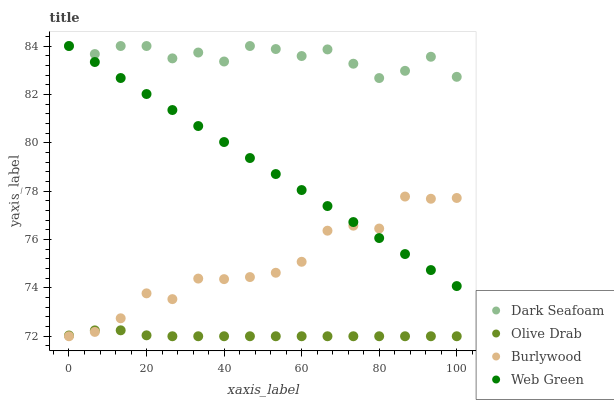Does Olive Drab have the minimum area under the curve?
Answer yes or no. Yes. Does Dark Seafoam have the maximum area under the curve?
Answer yes or no. Yes. Does Web Green have the minimum area under the curve?
Answer yes or no. No. Does Web Green have the maximum area under the curve?
Answer yes or no. No. Is Web Green the smoothest?
Answer yes or no. Yes. Is Burlywood the roughest?
Answer yes or no. Yes. Is Dark Seafoam the smoothest?
Answer yes or no. No. Is Dark Seafoam the roughest?
Answer yes or no. No. Does Burlywood have the lowest value?
Answer yes or no. Yes. Does Web Green have the lowest value?
Answer yes or no. No. Does Web Green have the highest value?
Answer yes or no. Yes. Does Olive Drab have the highest value?
Answer yes or no. No. Is Olive Drab less than Dark Seafoam?
Answer yes or no. Yes. Is Dark Seafoam greater than Burlywood?
Answer yes or no. Yes. Does Dark Seafoam intersect Web Green?
Answer yes or no. Yes. Is Dark Seafoam less than Web Green?
Answer yes or no. No. Is Dark Seafoam greater than Web Green?
Answer yes or no. No. Does Olive Drab intersect Dark Seafoam?
Answer yes or no. No. 